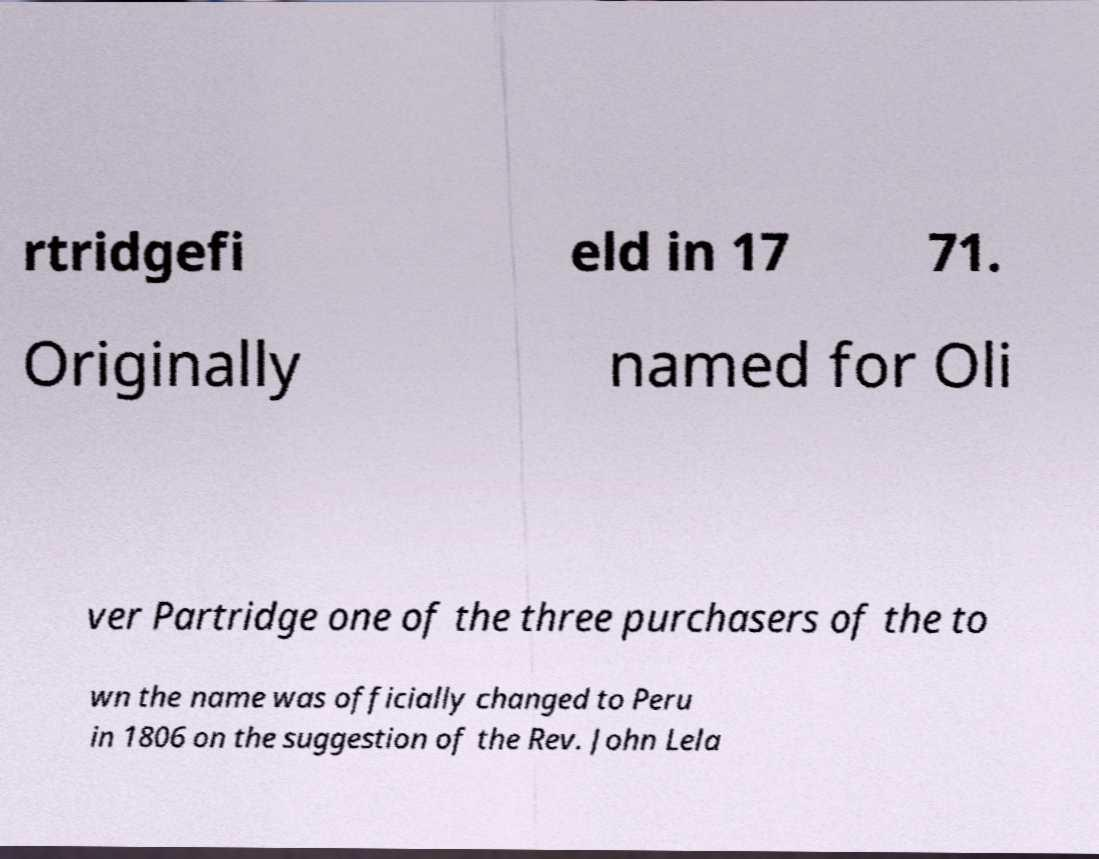Please read and relay the text visible in this image. What does it say? rtridgefi eld in 17 71. Originally named for Oli ver Partridge one of the three purchasers of the to wn the name was officially changed to Peru in 1806 on the suggestion of the Rev. John Lela 